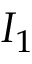Convert formula to latex. <formula><loc_0><loc_0><loc_500><loc_500>I _ { 1 }</formula> 